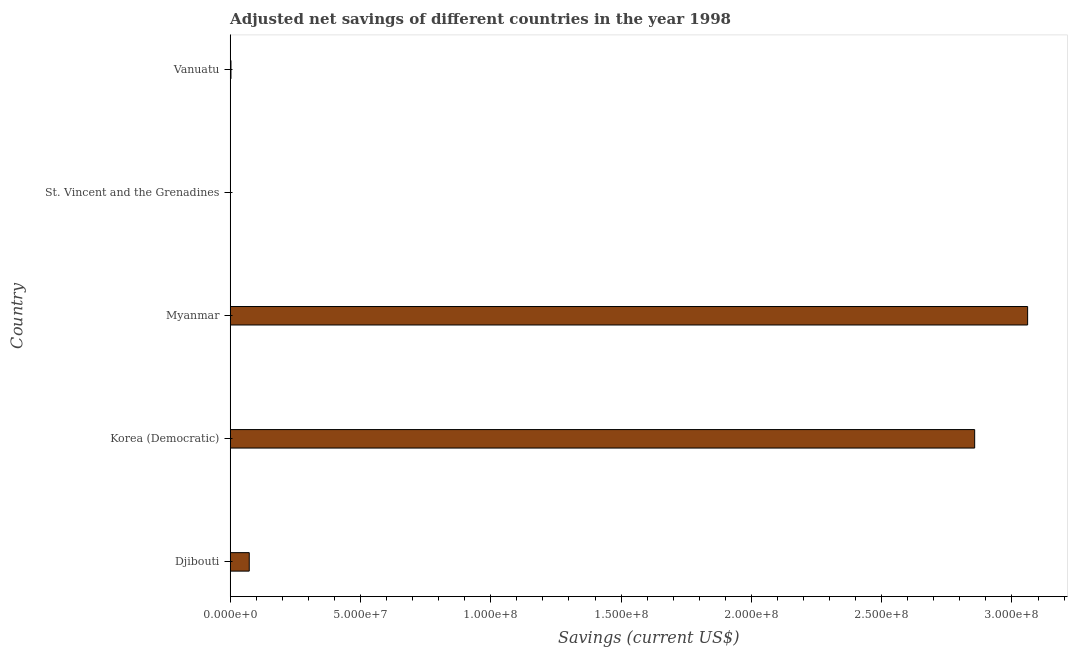What is the title of the graph?
Provide a short and direct response. Adjusted net savings of different countries in the year 1998. What is the label or title of the X-axis?
Your answer should be compact. Savings (current US$). What is the adjusted net savings in Korea (Democratic)?
Offer a terse response. 2.86e+08. Across all countries, what is the maximum adjusted net savings?
Your answer should be very brief. 3.06e+08. Across all countries, what is the minimum adjusted net savings?
Make the answer very short. 1.99e+04. In which country was the adjusted net savings maximum?
Offer a terse response. Myanmar. In which country was the adjusted net savings minimum?
Provide a short and direct response. St. Vincent and the Grenadines. What is the sum of the adjusted net savings?
Offer a very short reply. 5.99e+08. What is the difference between the adjusted net savings in Djibouti and Myanmar?
Provide a succinct answer. -2.99e+08. What is the average adjusted net savings per country?
Keep it short and to the point. 1.20e+08. What is the median adjusted net savings?
Offer a very short reply. 7.32e+06. What is the ratio of the adjusted net savings in Myanmar to that in St. Vincent and the Grenadines?
Your answer should be very brief. 1.54e+04. What is the difference between the highest and the second highest adjusted net savings?
Ensure brevity in your answer.  2.03e+07. Is the sum of the adjusted net savings in Myanmar and Vanuatu greater than the maximum adjusted net savings across all countries?
Give a very brief answer. Yes. What is the difference between the highest and the lowest adjusted net savings?
Provide a succinct answer. 3.06e+08. How many countries are there in the graph?
Keep it short and to the point. 5. What is the difference between two consecutive major ticks on the X-axis?
Ensure brevity in your answer.  5.00e+07. What is the Savings (current US$) in Djibouti?
Make the answer very short. 7.32e+06. What is the Savings (current US$) in Korea (Democratic)?
Offer a terse response. 2.86e+08. What is the Savings (current US$) in Myanmar?
Ensure brevity in your answer.  3.06e+08. What is the Savings (current US$) of St. Vincent and the Grenadines?
Provide a succinct answer. 1.99e+04. What is the Savings (current US$) in Vanuatu?
Make the answer very short. 2.99e+05. What is the difference between the Savings (current US$) in Djibouti and Korea (Democratic)?
Ensure brevity in your answer.  -2.78e+08. What is the difference between the Savings (current US$) in Djibouti and Myanmar?
Provide a short and direct response. -2.99e+08. What is the difference between the Savings (current US$) in Djibouti and St. Vincent and the Grenadines?
Give a very brief answer. 7.30e+06. What is the difference between the Savings (current US$) in Djibouti and Vanuatu?
Make the answer very short. 7.02e+06. What is the difference between the Savings (current US$) in Korea (Democratic) and Myanmar?
Give a very brief answer. -2.03e+07. What is the difference between the Savings (current US$) in Korea (Democratic) and St. Vincent and the Grenadines?
Your response must be concise. 2.86e+08. What is the difference between the Savings (current US$) in Korea (Democratic) and Vanuatu?
Your answer should be very brief. 2.85e+08. What is the difference between the Savings (current US$) in Myanmar and St. Vincent and the Grenadines?
Provide a short and direct response. 3.06e+08. What is the difference between the Savings (current US$) in Myanmar and Vanuatu?
Give a very brief answer. 3.06e+08. What is the difference between the Savings (current US$) in St. Vincent and the Grenadines and Vanuatu?
Your answer should be very brief. -2.79e+05. What is the ratio of the Savings (current US$) in Djibouti to that in Korea (Democratic)?
Offer a terse response. 0.03. What is the ratio of the Savings (current US$) in Djibouti to that in Myanmar?
Your answer should be compact. 0.02. What is the ratio of the Savings (current US$) in Djibouti to that in St. Vincent and the Grenadines?
Offer a very short reply. 368.32. What is the ratio of the Savings (current US$) in Djibouti to that in Vanuatu?
Your answer should be compact. 24.45. What is the ratio of the Savings (current US$) in Korea (Democratic) to that in Myanmar?
Provide a short and direct response. 0.93. What is the ratio of the Savings (current US$) in Korea (Democratic) to that in St. Vincent and the Grenadines?
Keep it short and to the point. 1.44e+04. What is the ratio of the Savings (current US$) in Korea (Democratic) to that in Vanuatu?
Provide a succinct answer. 954.88. What is the ratio of the Savings (current US$) in Myanmar to that in St. Vincent and the Grenadines?
Provide a short and direct response. 1.54e+04. What is the ratio of the Savings (current US$) in Myanmar to that in Vanuatu?
Offer a terse response. 1022.79. What is the ratio of the Savings (current US$) in St. Vincent and the Grenadines to that in Vanuatu?
Offer a very short reply. 0.07. 